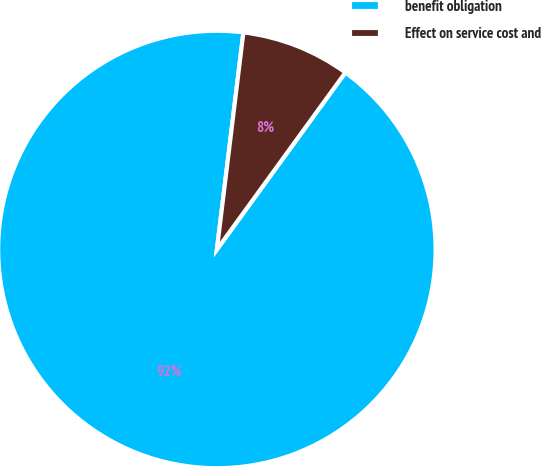Convert chart to OTSL. <chart><loc_0><loc_0><loc_500><loc_500><pie_chart><fcel>benefit obligation<fcel>Effect on service cost and<nl><fcel>91.94%<fcel>8.06%<nl></chart> 